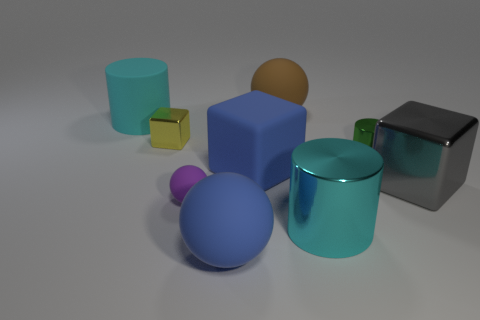There is a blue object behind the large sphere in front of the tiny green metallic cylinder; what is it made of?
Your answer should be compact. Rubber. What shape is the large matte thing that is the same color as the matte block?
Provide a short and direct response. Sphere. Is there a tiny blue cylinder made of the same material as the blue cube?
Offer a very short reply. No. What shape is the purple object?
Your answer should be compact. Sphere. How many big matte cubes are there?
Your answer should be compact. 1. There is a large block right of the metal cylinder on the left side of the green metal cylinder; what is its color?
Keep it short and to the point. Gray. The metallic cube that is the same size as the green object is what color?
Make the answer very short. Yellow. Is there a small shiny ball that has the same color as the big rubber block?
Give a very brief answer. No. Are any small matte cylinders visible?
Give a very brief answer. No. The yellow object to the left of the tiny green metallic object has what shape?
Your response must be concise. Cube. 